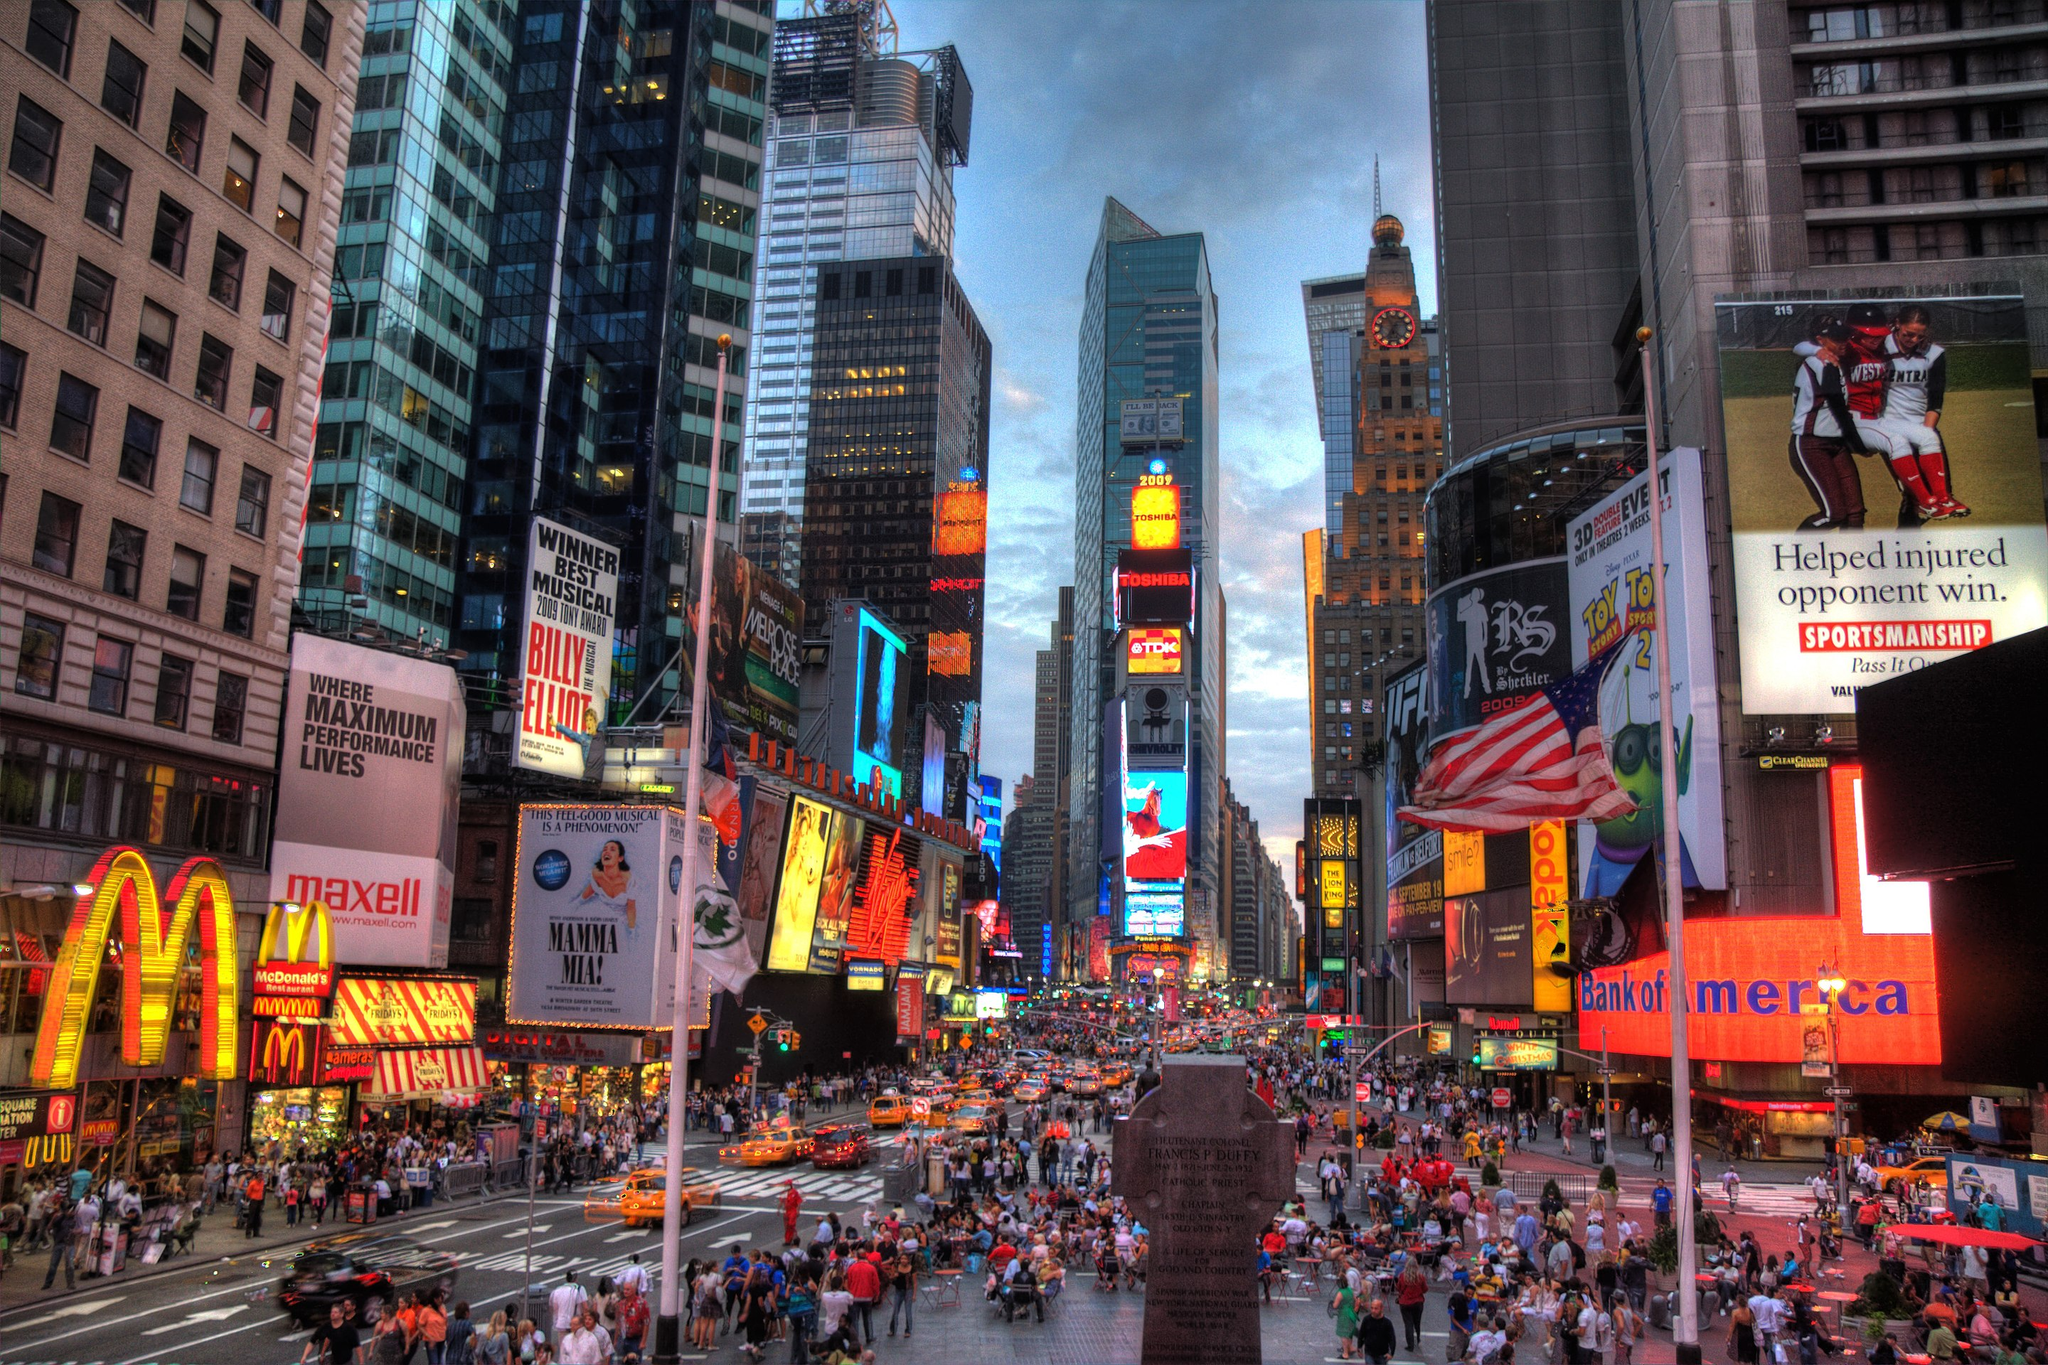How many buildings are in this image? The image shows numerous high-rise buildings and skyscrapers in a densely populated urban area, likely Times Square in New York City. There are multiple tall glass and steel buildings visible, as well as smaller commercial structures with various billboards, advertisements, and signs. It's a vibrant, bustling city scene with a large crowd of people visible on the streets below the buildings. 